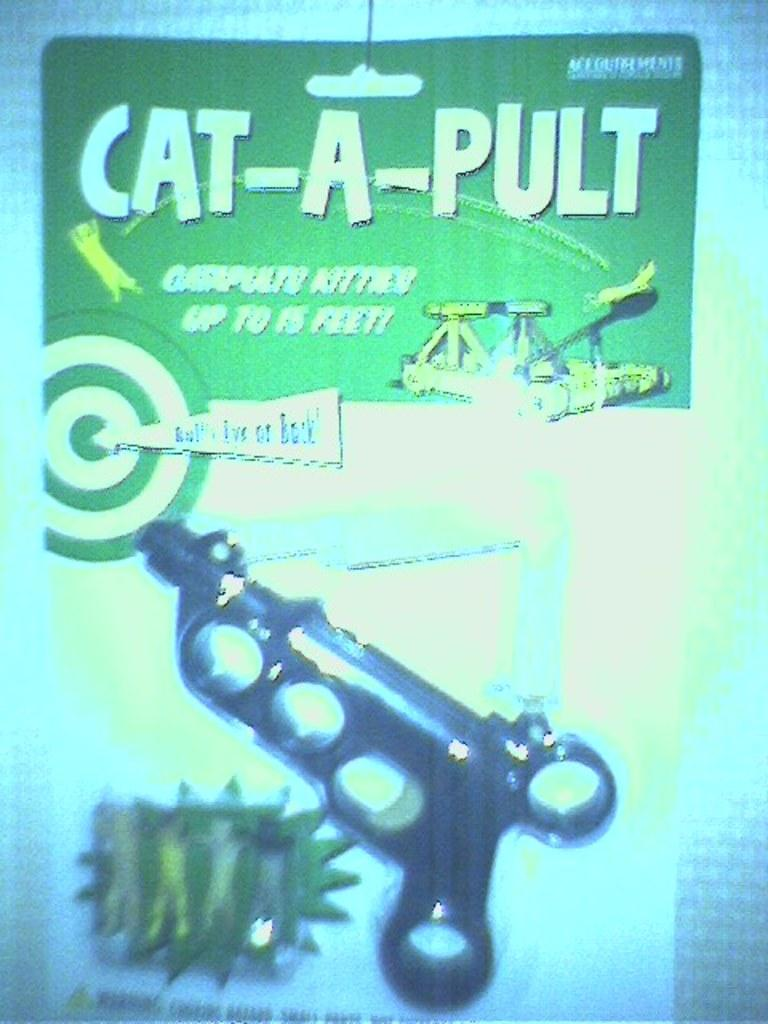What object is present in the image that is used for conveying information? There is a pamphlet in the image that is used for conveying information. What is the color of the pamphlet? The pamphlet is green in color. What other object is present in the image that is not related to the pamphlet? There is a black color gun in the image. What can be found on the pamphlet? There is writing on the pamphlet. How many strings are attached to the pamphlet in the image? There are no strings attached to the pamphlet in the image. What type of exchange is taking place between the pamphlet and the gun in the image? There is no exchange taking place between the pamphlet and the gun in the image; they are separate objects. 